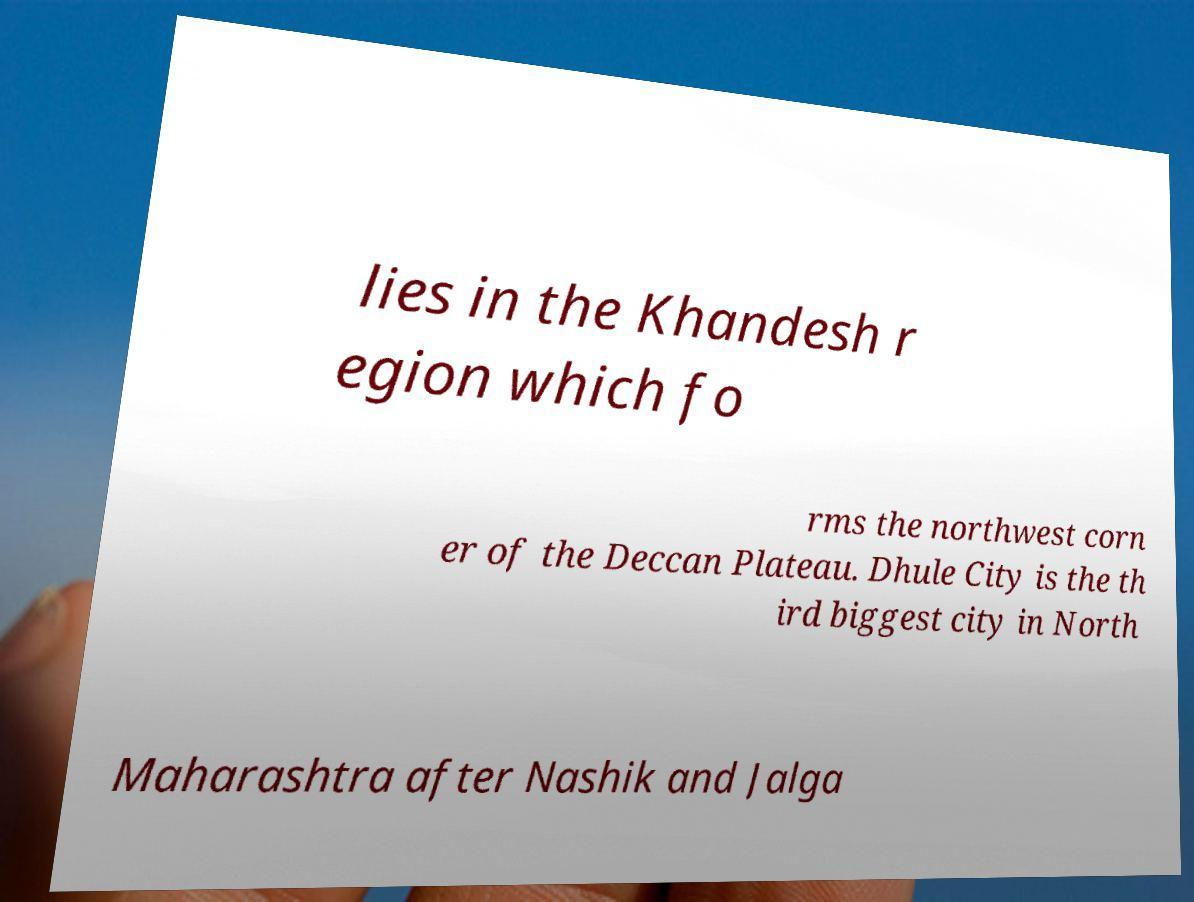For documentation purposes, I need the text within this image transcribed. Could you provide that? lies in the Khandesh r egion which fo rms the northwest corn er of the Deccan Plateau. Dhule City is the th ird biggest city in North Maharashtra after Nashik and Jalga 